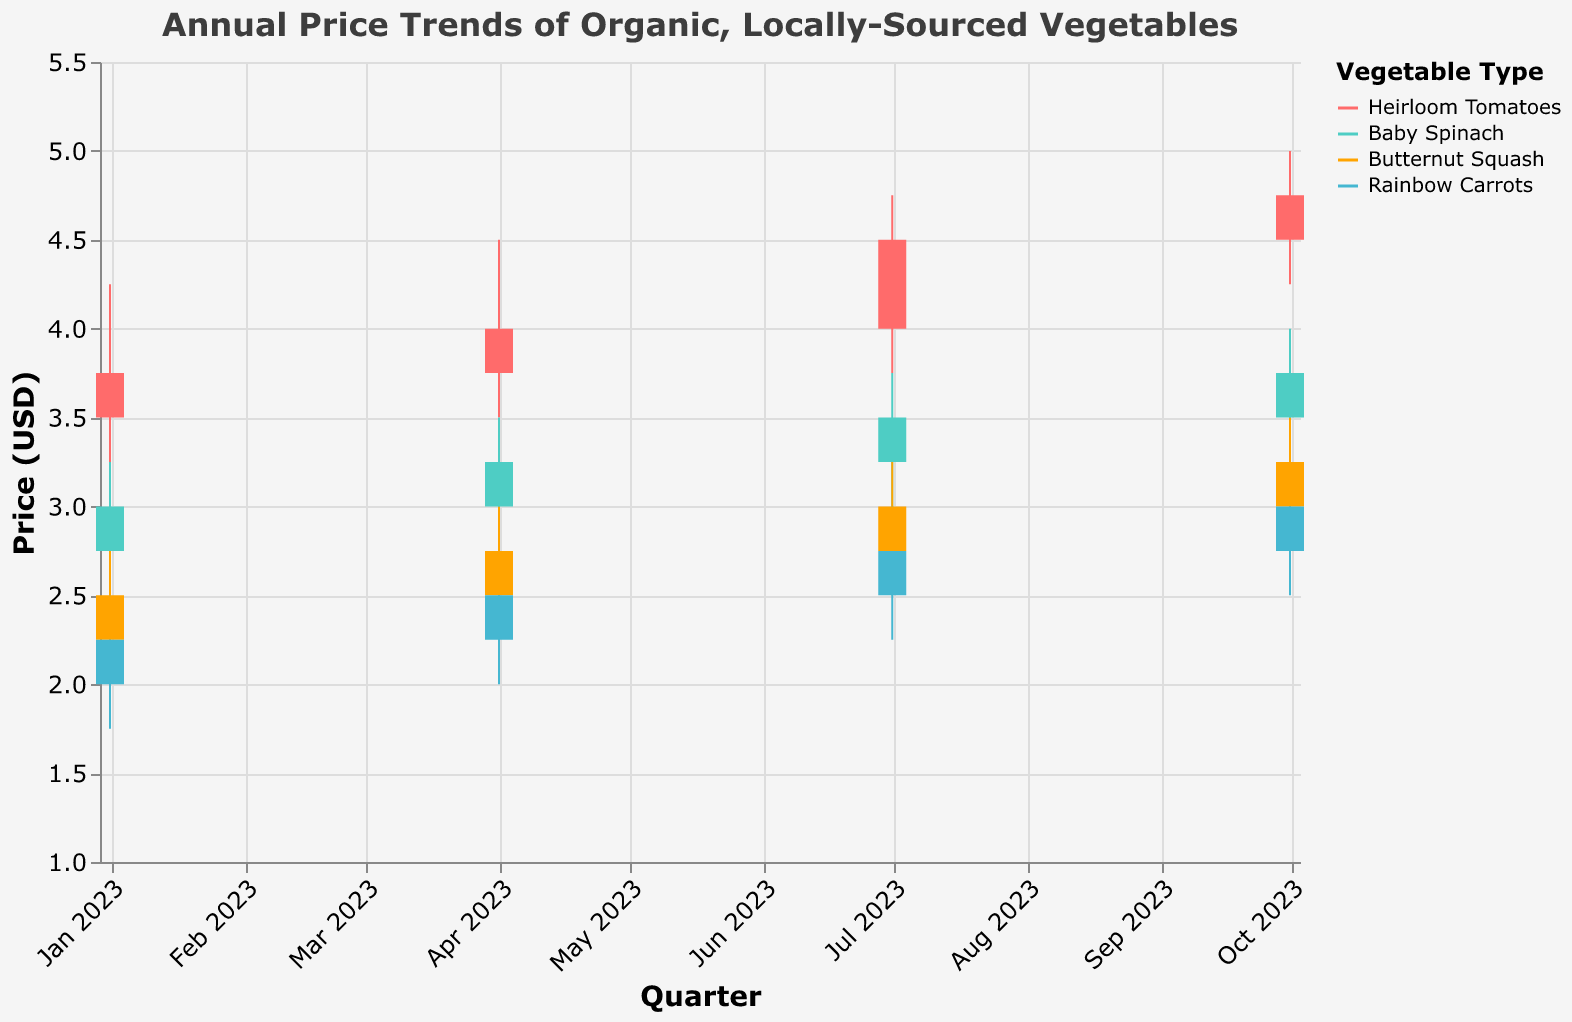How does the price of Heirloom Tomatoes change from January to October 2023? To determine the price change, look at the closing prices for Heirloom Tomatoes from January 1st, 2023, to October 1st, 2023. The closing price in January is $3.75 and in October is $4.75. Subtract the January price from the October price to find the change.
Answer: $1.00 Which vegetable had the highest closing price in October 2023? Examine the closing prices in the figure for October 2023 for all vegetables. Heirloom Tomatoes closed at $4.75, Baby Spinach at $3.75, Butternut Squash at $3.25, and Rainbow Carrots at $3.00. The highest closing price is for Heirloom Tomatoes.
Answer: Heirloom Tomatoes What is the average closing price of Rainbow Carrots throughout 2023? To find the average closing price, add up the closing prices of Rainbow Carrots for January, April, July, and October, then divide by the number of data points. The closing prices are $2.25, $2.50, $2.75, and $3.00. The sum is $10.50, and there are 4 data points. Divide $10.50 by 4 to get the average.
Answer: $2.625 Between Baby Spinach and Butternut Squash, which one has a more significant price increase from January to October 2023? Calculate the price change for each vegetable from January to October. For Baby Spinach, the price increases from $3.00 to $3.75, a $0.75 increase. For Butternut Squash, the price increases from $2.50 to $3.25, a $0.75 increase. Both have the same price increase.
Answer: Both have the same increase How many distinct colors are used to represent different vegetables in the figure? The figure uses different colors to represent each type of vegetable. Identify the distinct colors used for Heirloom Tomatoes, Baby Spinach, Butternut Squash, and Rainbow Carrots. These are visually identifiable as red, teal, orange, and blue respectively.
Answer: 4 